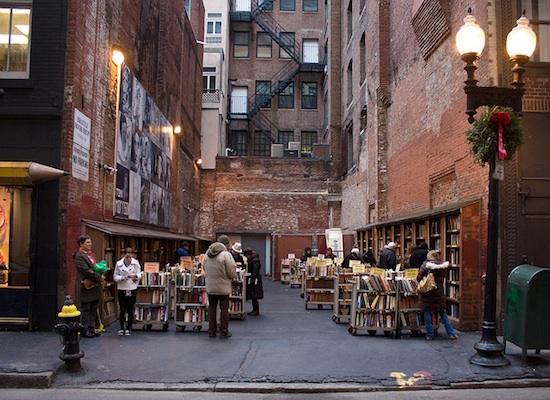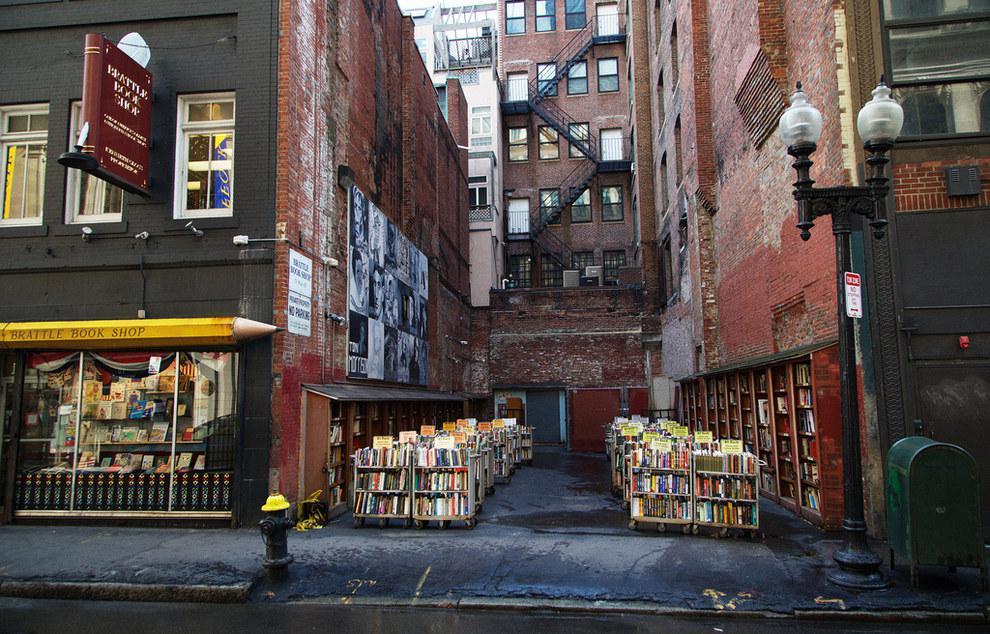The first image is the image on the left, the second image is the image on the right. Given the left and right images, does the statement "A red sign is attached and perpendicular next to a window of a dark colored building." hold true? Answer yes or no. Yes. The first image is the image on the left, the second image is the image on the right. Examine the images to the left and right. Is the description "Right image shows people browsing bookshelves topped with orange signs, located in a space partly surrounded by brick walls." accurate? Answer yes or no. No. The first image is the image on the left, the second image is the image on the right. Assess this claim about the two images: "Both are exterior views, but only the right image shows a yellow pencil shape pointing toward an area between brick buildings where wheeled carts of books are topped with yellow signs.". Correct or not? Answer yes or no. No. The first image is the image on the left, the second image is the image on the right. Assess this claim about the two images: "People are looking at books in an alley in the image on the right.". Correct or not? Answer yes or no. No. 